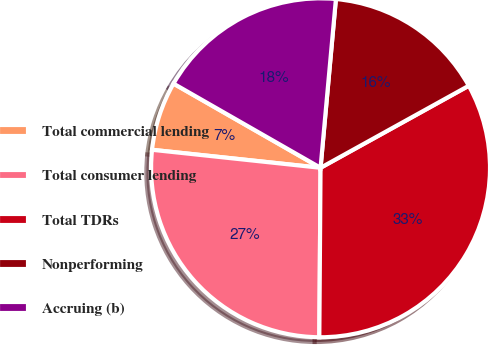<chart> <loc_0><loc_0><loc_500><loc_500><pie_chart><fcel>Total commercial lending<fcel>Total consumer lending<fcel>Total TDRs<fcel>Nonperforming<fcel>Accruing (b)<nl><fcel>6.58%<fcel>26.58%<fcel>33.16%<fcel>15.51%<fcel>18.17%<nl></chart> 